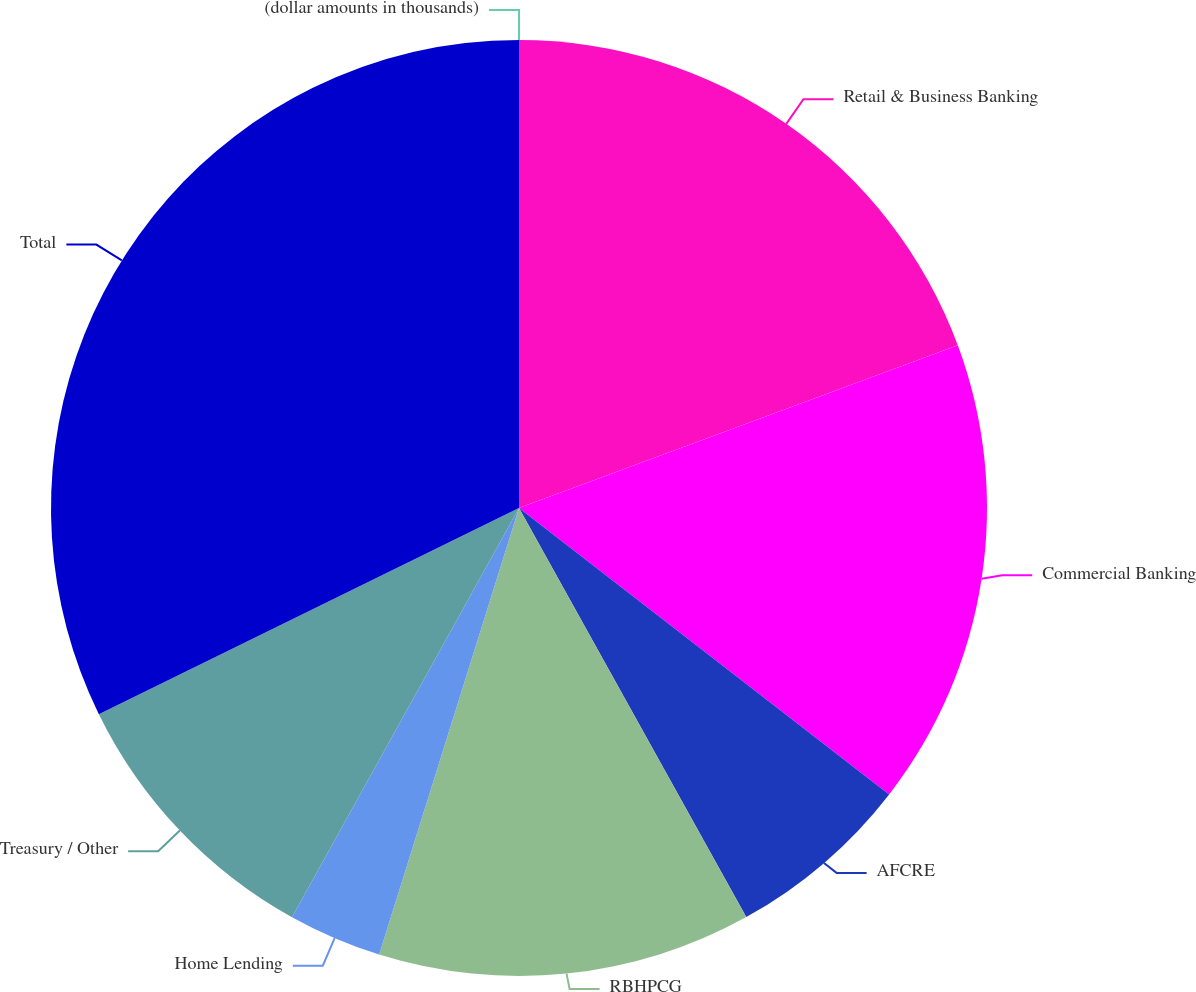Convert chart to OTSL. <chart><loc_0><loc_0><loc_500><loc_500><pie_chart><fcel>(dollar amounts in thousands)<fcel>Retail & Business Banking<fcel>Commercial Banking<fcel>AFCRE<fcel>RBHPCG<fcel>Home Lending<fcel>Treasury / Other<fcel>Total<nl><fcel>0.0%<fcel>19.35%<fcel>16.13%<fcel>6.45%<fcel>12.9%<fcel>3.23%<fcel>9.68%<fcel>32.26%<nl></chart> 